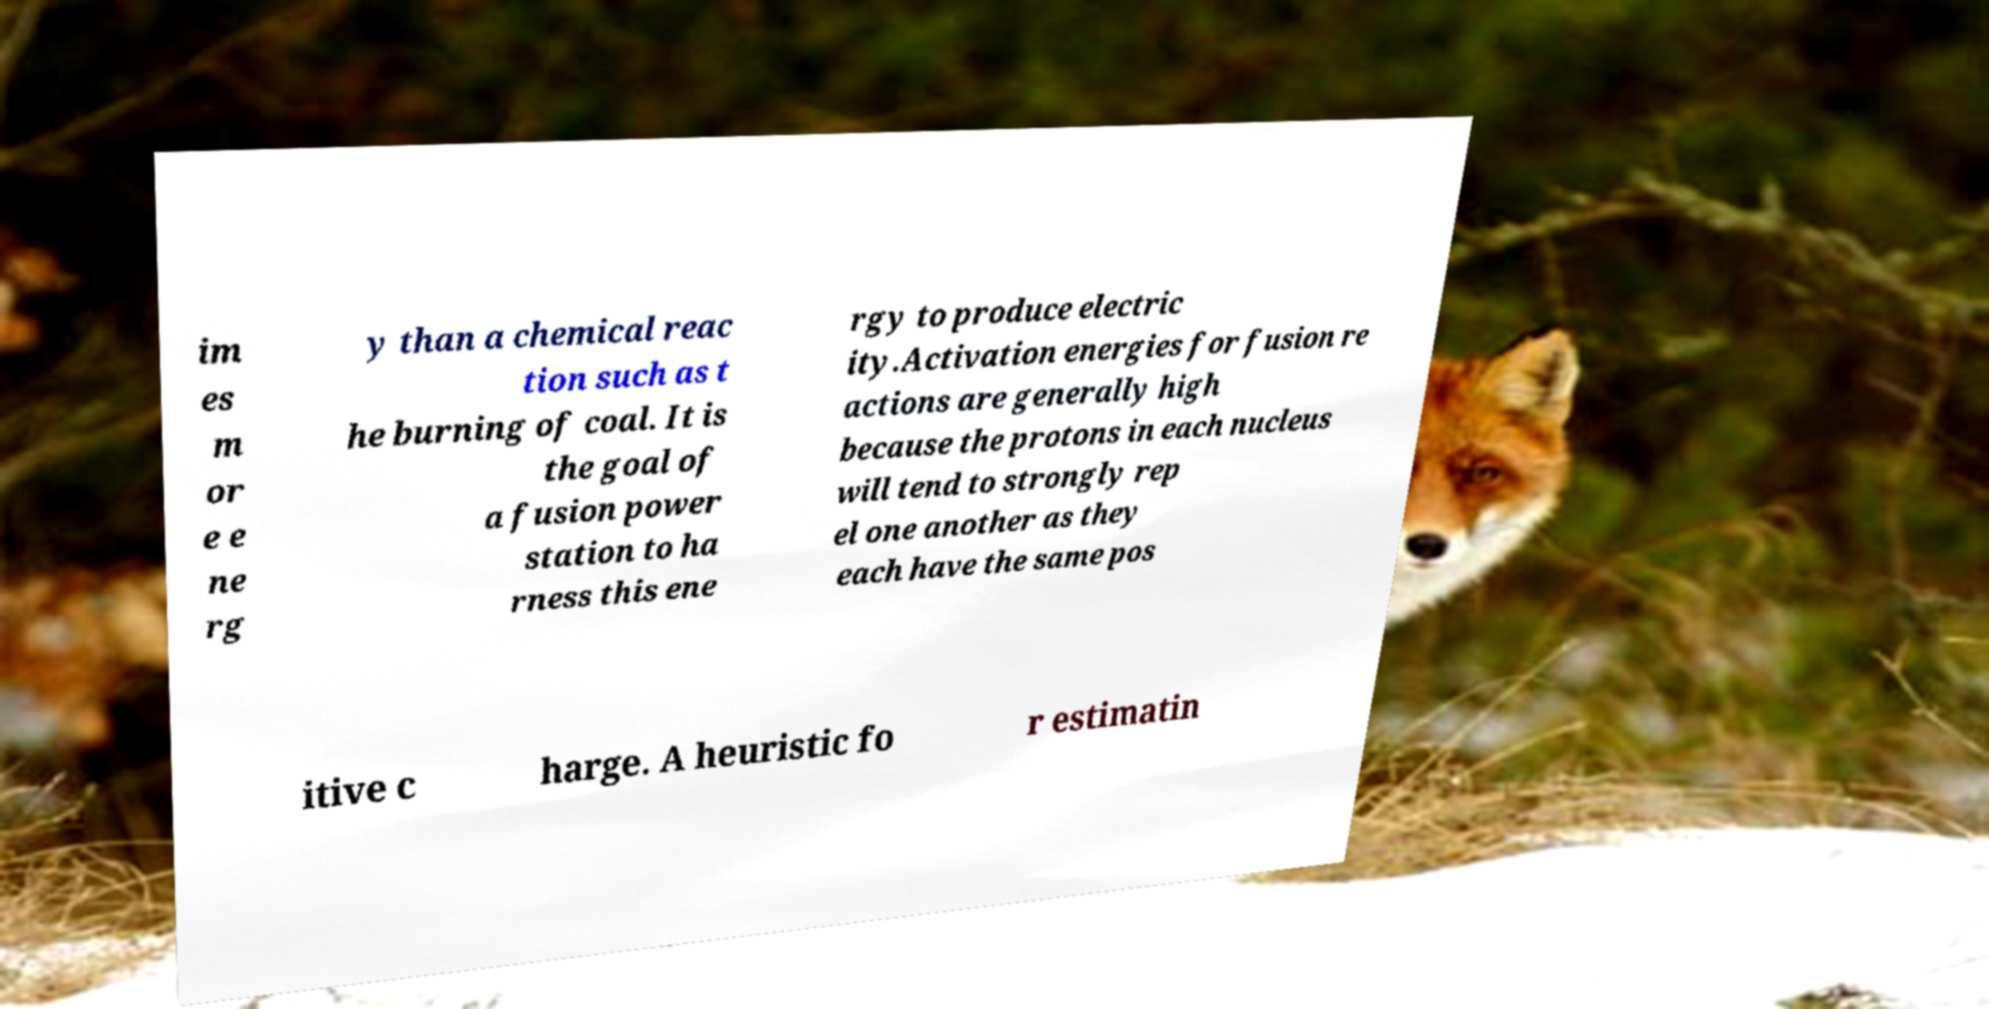What messages or text are displayed in this image? I need them in a readable, typed format. im es m or e e ne rg y than a chemical reac tion such as t he burning of coal. It is the goal of a fusion power station to ha rness this ene rgy to produce electric ity.Activation energies for fusion re actions are generally high because the protons in each nucleus will tend to strongly rep el one another as they each have the same pos itive c harge. A heuristic fo r estimatin 